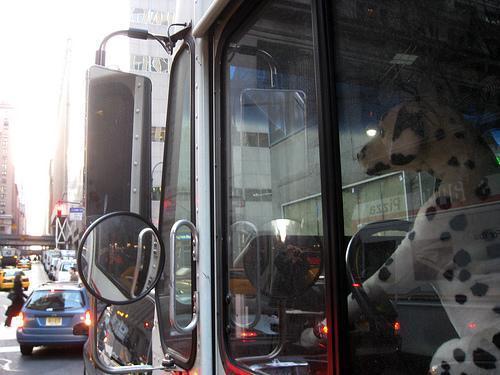How many dogs are pictured?
Give a very brief answer. 1. How many people can be seen crossing the street?
Give a very brief answer. 2. 